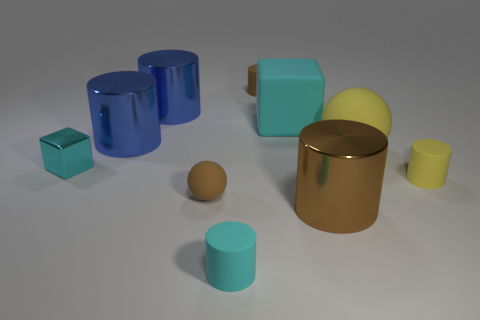There is a sphere left of the cyan matte thing in front of the large brown metal cylinder; what is its color?
Offer a very short reply. Brown. Is the number of small matte cylinders on the left side of the brown shiny thing greater than the number of cyan rubber objects that are to the right of the yellow ball?
Offer a terse response. Yes. Is the material of the sphere that is on the left side of the big sphere the same as the brown cylinder in front of the tiny yellow matte cylinder?
Your answer should be compact. No. Are there any large metal things in front of the cyan cylinder?
Your response must be concise. No. What number of blue things are either tiny balls or rubber objects?
Your response must be concise. 0. Does the big ball have the same material as the large cylinder in front of the tiny yellow rubber thing?
Provide a succinct answer. No. What is the size of the cyan rubber object that is the same shape as the small yellow rubber object?
Your response must be concise. Small. What is the material of the large brown cylinder?
Ensure brevity in your answer.  Metal. What material is the large cylinder that is to the left of the large blue cylinder that is behind the cube on the right side of the tiny cyan shiny block?
Offer a very short reply. Metal. There is a brown matte object in front of the large rubber block; is its size the same as the matte cylinder that is in front of the yellow rubber cylinder?
Give a very brief answer. Yes. 